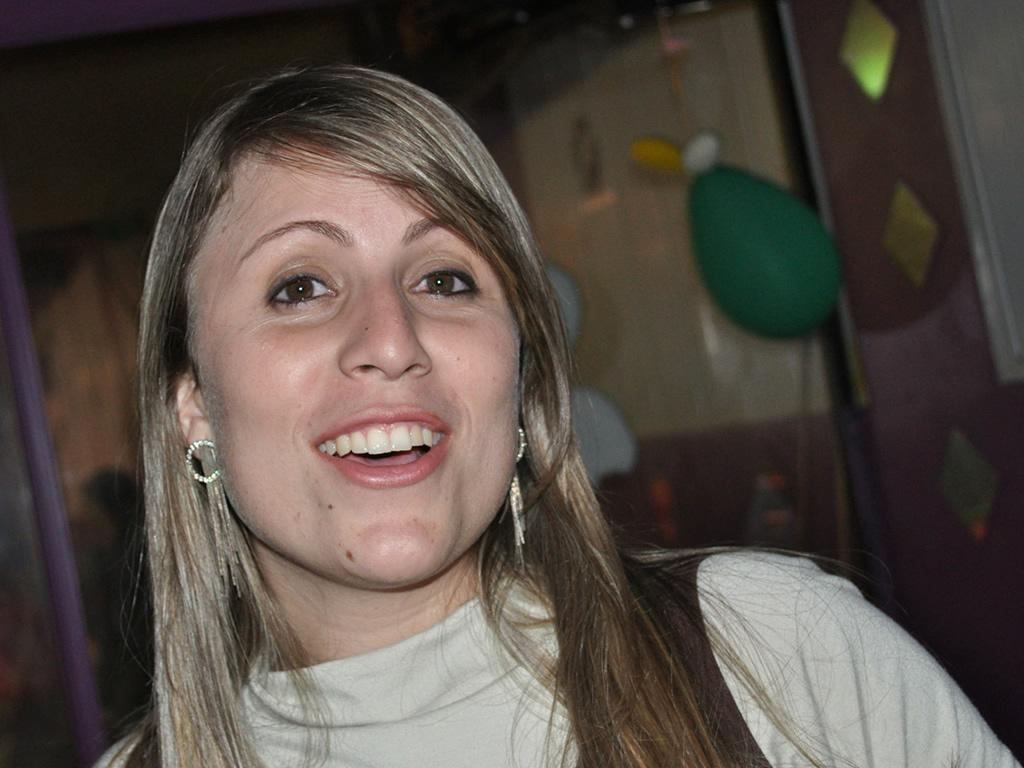Who is present in the image? There is a woman in the image. What is the woman wearing in the image? The woman is wearing earrings. What is the woman's facial expression in the image? The woman is smiling. What can be seen in the background of the image? There is a pole and colorful objects in the background of the image. What angle is the self-expert standing at in the image? There is no self-expert present in the image, and the concept of an angle is not relevant to the description of the woman's position. 